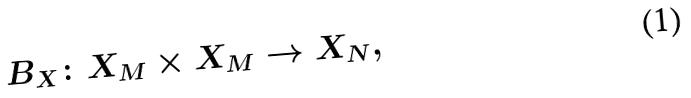Convert formula to latex. <formula><loc_0><loc_0><loc_500><loc_500>B _ { X } \colon X _ { M } \times X _ { M } \to X _ { N } ,</formula> 